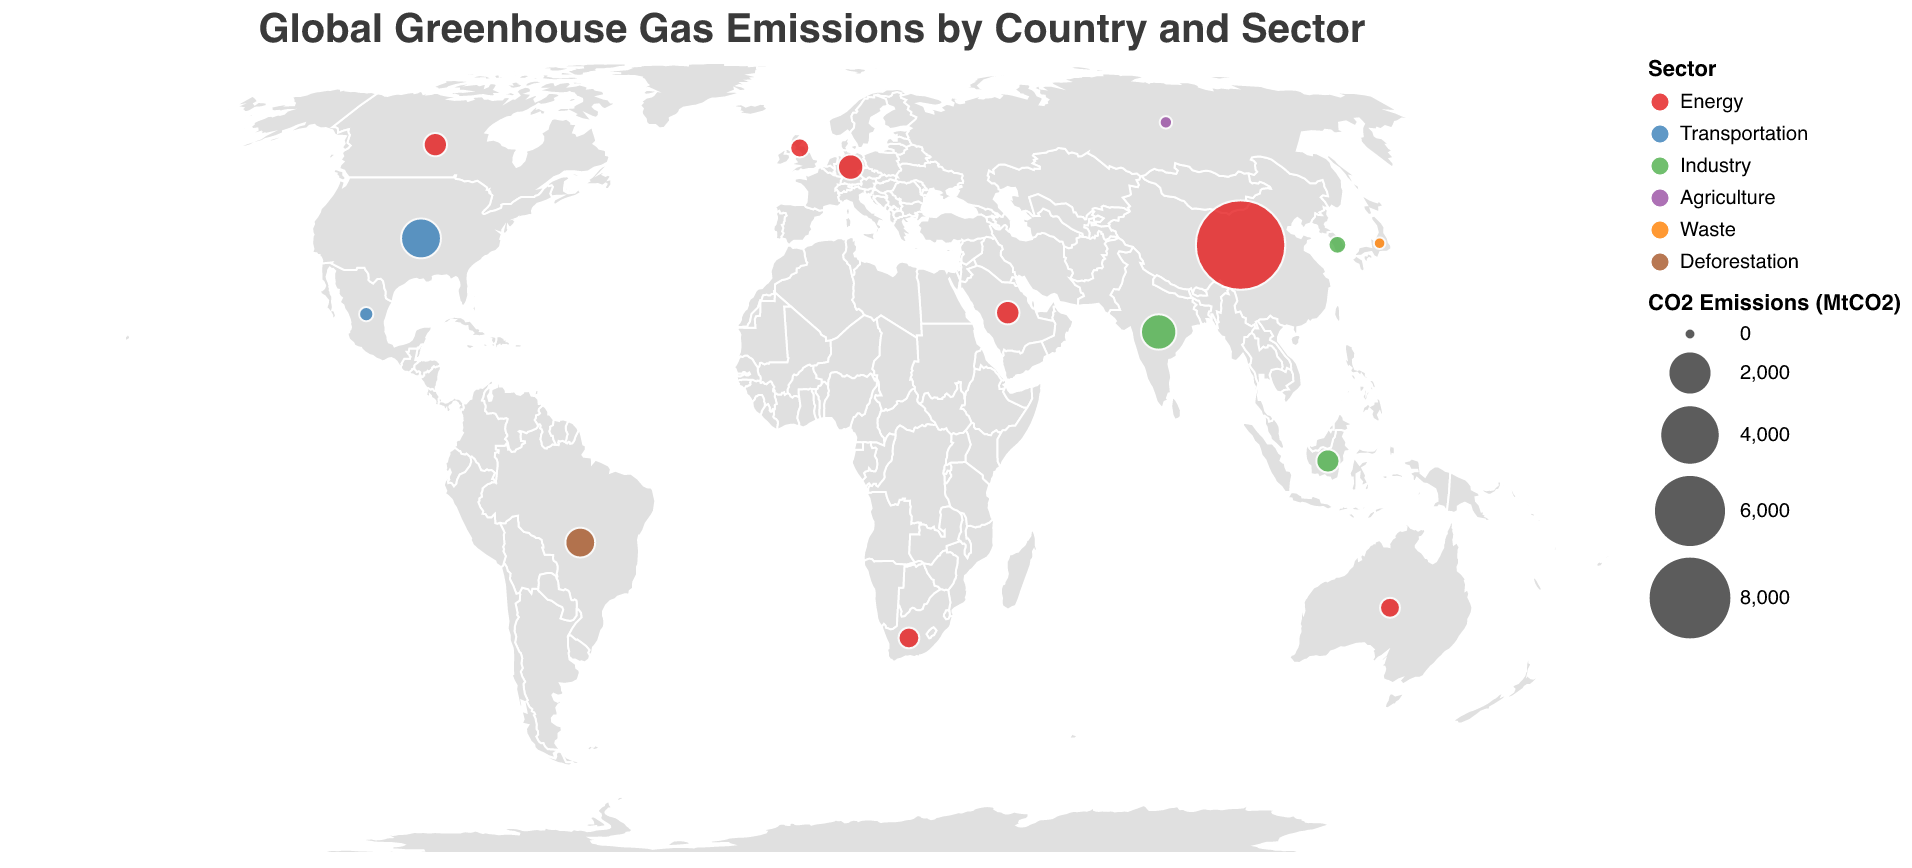Which country has the highest CO2 emissions? To determine the country with the highest CO2 emissions, we look at the size of the circles and focus on the country that has the largest circle in the figure. The country with the largest circle is China.
Answer: China In which sector does the United States have the highest emissions? By locating the United States on the map and looking at the tooltip information, we see that the United States' CO2 emissions are represented by the blue circle, which is associated with the Transportation sector according to the color legend.
Answer: Transportation What is the total CO2 emissions from the Energy sector across all countries? To find the total CO2 emissions from the Energy sector, we need to add up the CO2 emissions of all countries where the sector is energy: China (9825.8), Germany (701.6), Canada (573.9), Australia (392.1), Saudi Arabia (582.4), United Kingdom (351.5), and South Africa (435.8). The sum is 9825.8 + 701.6 + 573.9 + 392.1 + 582.4 + 351.5 + 435.8 = 12863.1 MtCO2.
Answer: 12863.1 MtCO2 How do the CO2 emissions from 'Industry' in India compare to those in South Korea? By observing the sizes of the circles representing Industry in both countries, India has emissions of 1452.2 MtCO2 and South Korea has emissions of 292.5 MtCO2. Thus, India's emissions are significantly higher.
Answer: India has higher emissions Which country in the Southern Hemisphere has the highest CO2 emissions from Deforestation? To identify this, we first look at the Southern Hemisphere countries in the list. Brazil is the only one associated with the Deforestation sector. Brazil's CO2 emissions from Deforestation are 1002.3 MtCO2, making it the highest by default.
Answer: Brazil How does the total CO2 emissions from the Transportation sector in the United States compare to the total emissions from the Transportation sector in Mexico? Locating both the United States and Mexico on the map, we see that the CO2 emissions for the United States are 1875.7 MtCO2 and for Mexico are 154.3 MtCO2. Comparing the two values shows that the United States has significantly higher emissions.
Answer: United States has higher emissions What is the main contributing sector to greenhouse gases for Russia? By finding Russia on the map and examining the tooltip, we see that the sector associated with Russia is Agriculture, as indicated by the purple color in the legend.
Answer: Agriculture Which country emits the least CO2 in the Waste sector? Looking at the data for the Waste sector, only Japan is represented with CO2 emissions of 67.5 MtCO2, making it both the least and the only country in this sector.
Answer: Japan What is the average CO2 emission for the countries in the Energy sector? To find the average, sum the CO2 emissions of the countries in the Energy sector and divide by the number of countries. The emissions are China (9825.8), Germany (701.6), Canada (573.9), Australia (392.1), Saudi Arabia (582.4), United Kingdom (351.5), and South Africa (435.8). The sum is 12863.1 and there are 7 countries, thus the average is 12863.1 / 7 ≈ 1837.6 MtCO2.
Answer: 1837.6 MtCO2 